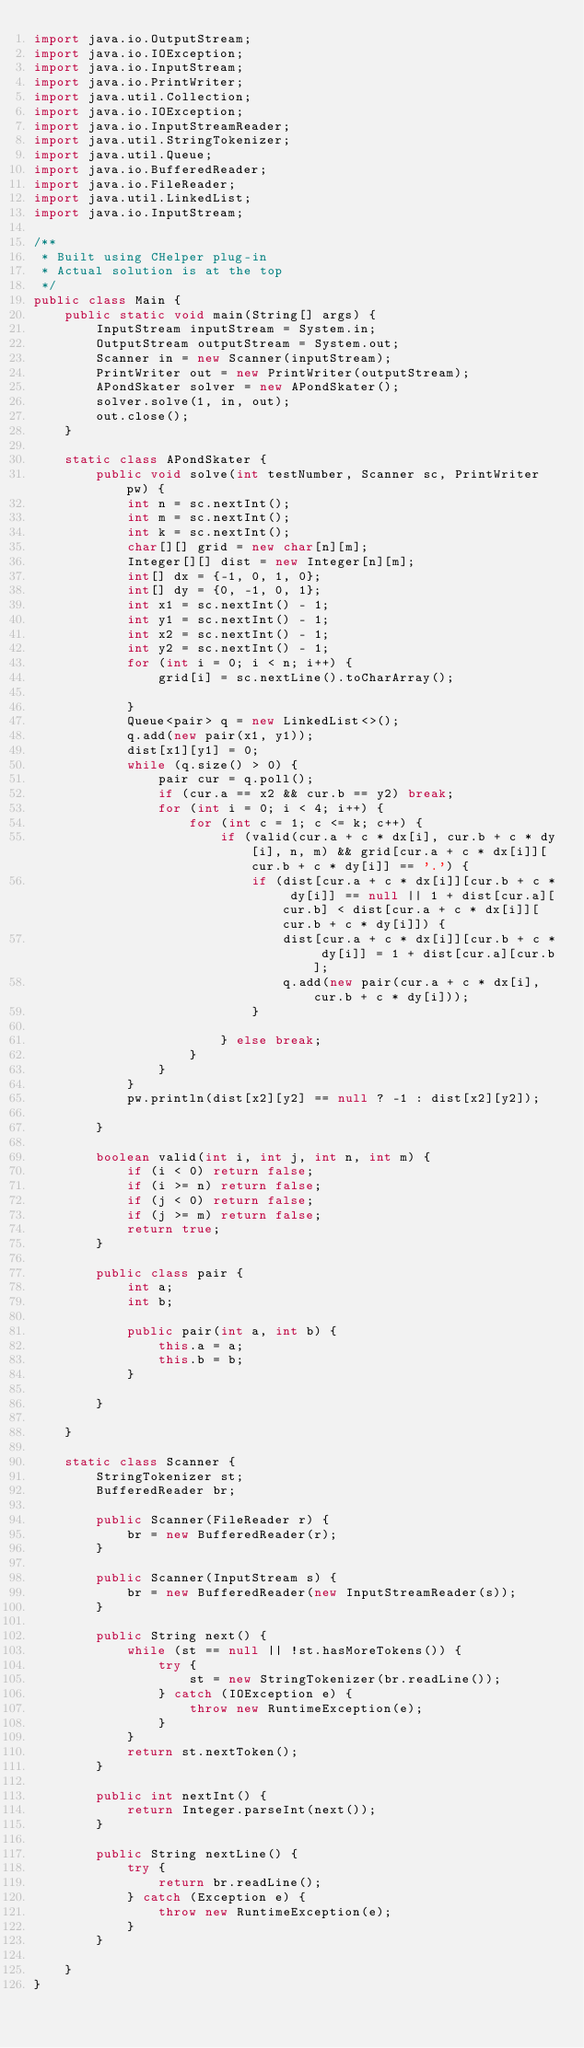<code> <loc_0><loc_0><loc_500><loc_500><_Java_>import java.io.OutputStream;
import java.io.IOException;
import java.io.InputStream;
import java.io.PrintWriter;
import java.util.Collection;
import java.io.IOException;
import java.io.InputStreamReader;
import java.util.StringTokenizer;
import java.util.Queue;
import java.io.BufferedReader;
import java.io.FileReader;
import java.util.LinkedList;
import java.io.InputStream;

/**
 * Built using CHelper plug-in
 * Actual solution is at the top
 */
public class Main {
    public static void main(String[] args) {
        InputStream inputStream = System.in;
        OutputStream outputStream = System.out;
        Scanner in = new Scanner(inputStream);
        PrintWriter out = new PrintWriter(outputStream);
        APondSkater solver = new APondSkater();
        solver.solve(1, in, out);
        out.close();
    }

    static class APondSkater {
        public void solve(int testNumber, Scanner sc, PrintWriter pw) {
            int n = sc.nextInt();
            int m = sc.nextInt();
            int k = sc.nextInt();
            char[][] grid = new char[n][m];
            Integer[][] dist = new Integer[n][m];
            int[] dx = {-1, 0, 1, 0};
            int[] dy = {0, -1, 0, 1};
            int x1 = sc.nextInt() - 1;
            int y1 = sc.nextInt() - 1;
            int x2 = sc.nextInt() - 1;
            int y2 = sc.nextInt() - 1;
            for (int i = 0; i < n; i++) {
                grid[i] = sc.nextLine().toCharArray();

            }
            Queue<pair> q = new LinkedList<>();
            q.add(new pair(x1, y1));
            dist[x1][y1] = 0;
            while (q.size() > 0) {
                pair cur = q.poll();
                if (cur.a == x2 && cur.b == y2) break;
                for (int i = 0; i < 4; i++) {
                    for (int c = 1; c <= k; c++) {
                        if (valid(cur.a + c * dx[i], cur.b + c * dy[i], n, m) && grid[cur.a + c * dx[i]][cur.b + c * dy[i]] == '.') {
                            if (dist[cur.a + c * dx[i]][cur.b + c * dy[i]] == null || 1 + dist[cur.a][cur.b] < dist[cur.a + c * dx[i]][cur.b + c * dy[i]]) {
                                dist[cur.a + c * dx[i]][cur.b + c * dy[i]] = 1 + dist[cur.a][cur.b];
                                q.add(new pair(cur.a + c * dx[i], cur.b + c * dy[i]));
                            }

                        } else break;
                    }
                }
            }
            pw.println(dist[x2][y2] == null ? -1 : dist[x2][y2]);

        }

        boolean valid(int i, int j, int n, int m) {
            if (i < 0) return false;
            if (i >= n) return false;
            if (j < 0) return false;
            if (j >= m) return false;
            return true;
        }

        public class pair {
            int a;
            int b;

            public pair(int a, int b) {
                this.a = a;
                this.b = b;
            }

        }

    }

    static class Scanner {
        StringTokenizer st;
        BufferedReader br;

        public Scanner(FileReader r) {
            br = new BufferedReader(r);
        }

        public Scanner(InputStream s) {
            br = new BufferedReader(new InputStreamReader(s));
        }

        public String next() {
            while (st == null || !st.hasMoreTokens()) {
                try {
                    st = new StringTokenizer(br.readLine());
                } catch (IOException e) {
                    throw new RuntimeException(e);
                }
            }
            return st.nextToken();
        }

        public int nextInt() {
            return Integer.parseInt(next());
        }

        public String nextLine() {
            try {
                return br.readLine();
            } catch (Exception e) {
                throw new RuntimeException(e);
            }
        }

    }
}

</code> 